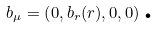Convert formula to latex. <formula><loc_0><loc_0><loc_500><loc_500>b _ { \mu } = \left ( 0 , b _ { r } ( r ) , 0 , 0 \right ) \text {.}</formula> 